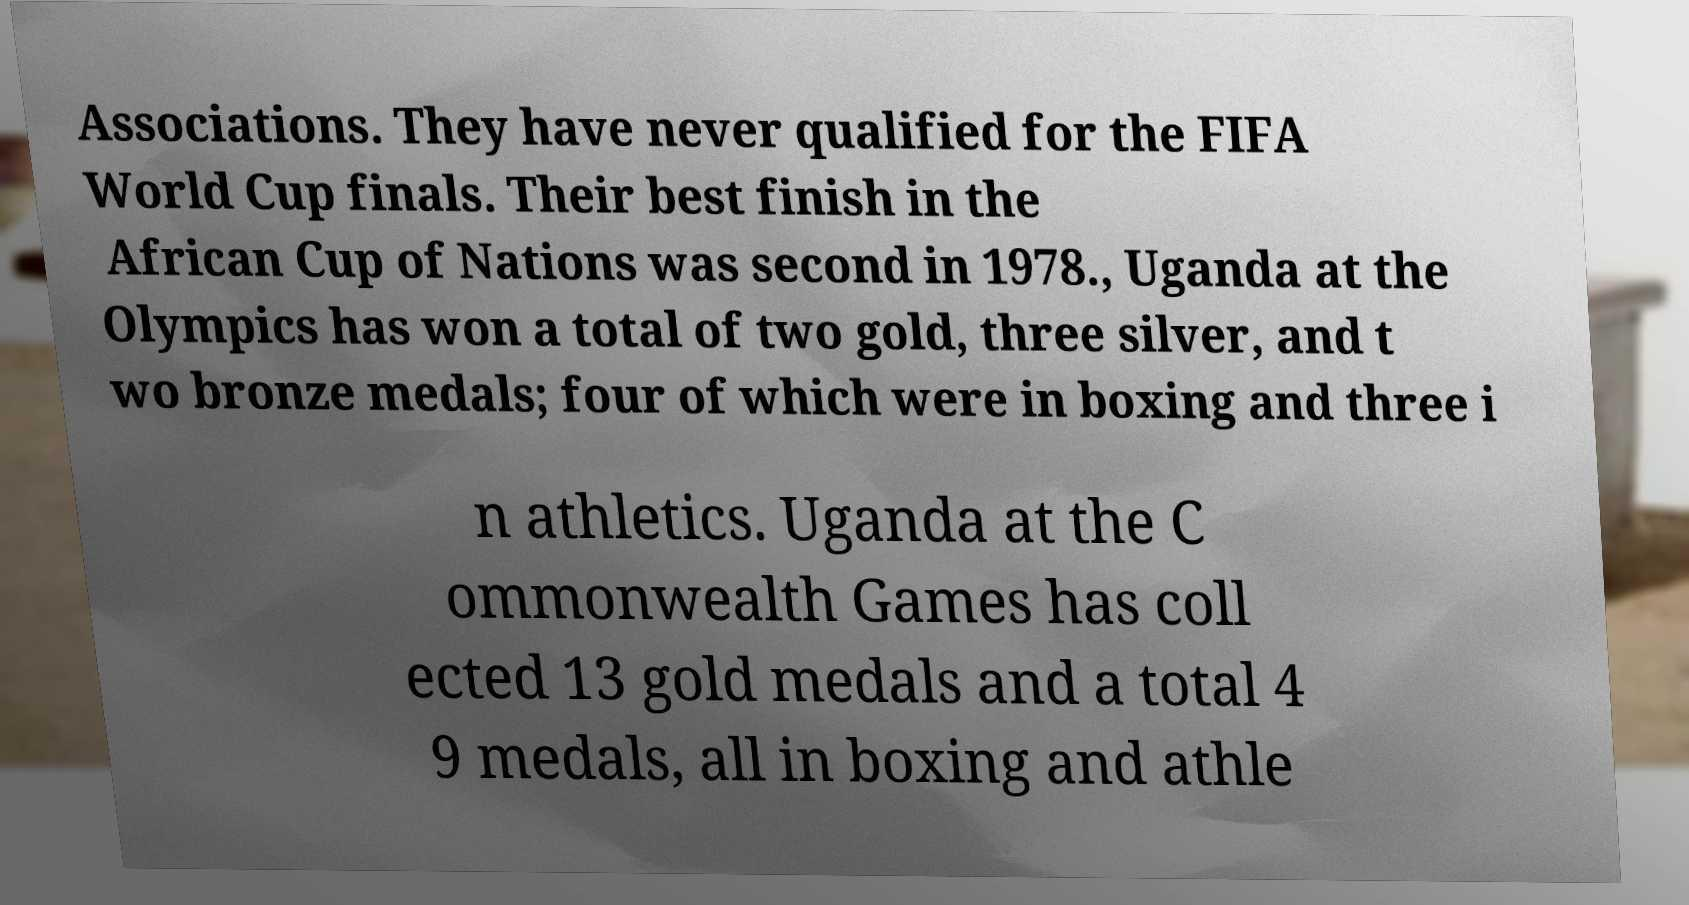There's text embedded in this image that I need extracted. Can you transcribe it verbatim? Associations. They have never qualified for the FIFA World Cup finals. Their best finish in the African Cup of Nations was second in 1978., Uganda at the Olympics has won a total of two gold, three silver, and t wo bronze medals; four of which were in boxing and three i n athletics. Uganda at the C ommonwealth Games has coll ected 13 gold medals and a total 4 9 medals, all in boxing and athle 